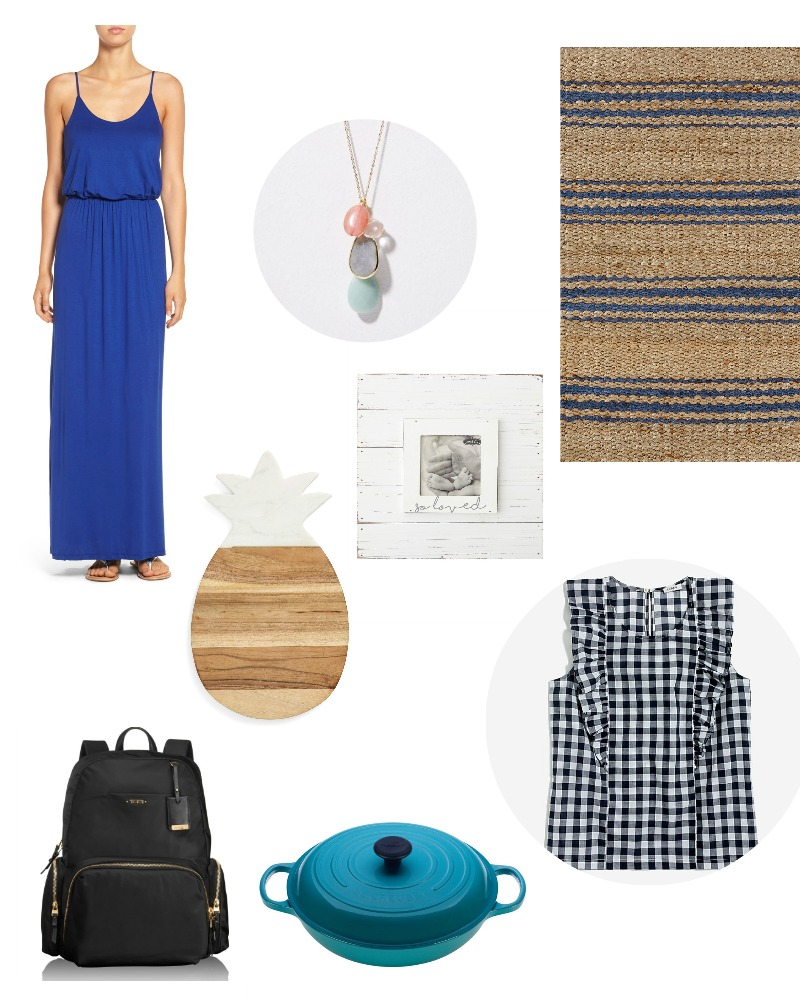Can you tell a detailed story or create a fictional scenario around the items shown in the image? Once upon a time, in a quaint little cottage on the edge of a bustling town, lived a woman named Clara. Clara adored her home, which was a blend of rustic charm and modern elegance. One sunny Saturday morning, she decided to host a small gathering for her closest friends and family. 

Clara wore a stunning blue dress, simple yet elegant, perfect for the warm weather. She teamed it up with a delicate necklace, adding a touch of grace to her attire. Her best friend Jane arrived early, wearing a stylish checkered top, ready to help Clara with the preparations. 

They began by arranging the living room, spreading out a jute rug that gave a natural, earthy feel to the space. On the kitchen countertop, they placed a beautifully crafted pineapple cutting board, a favorite of Clara’s for its unique design.

Cooking was Clara’s passion, and she loved using her teal cast iron pot to prepare delicious meals. Today, she decided to make a hearty stew. As she cooked, Jane arranged snacks and drinks in the living room. The rustic wooden frame holding a cherished black and white family photo was placed in a prominent spot, reminding everyone of the bond they shared.

Clara’s daughter, Lily, entered the scene carrying a sleek black backpack. She had just returned from an errand, and the gold details of her bag caught everyone’s eye. The backpack was practical yet stylish, a perfect reflection of Lily’s personality.

As the house filled with the rich aroma of stew and the sound of laughter, Clara looked around, feeling a sense of warmth and contentment. The items in her home, simple yet thoughtfully selected, contributed to a space that was welcoming and filled with love. The day was a beautiful medley of good food, great company, and memorable moments. What if these items were part of a mystery story? How would they fit into the plot? In the quiet town of Willow Creek, where everyone knew everyone, an unexpected mystery began to unfold. Clara, a local artist, was the center of attention when a valuable piece of her artwork went missing. The only clues left behind were seemingly mundane household items, yet each held a deeper significance. 

The detective, a sharp-eyed sleuth with a penchant for detail, began his investigation in Clara's home. Clara had worn a blue dress on the night of the theft, the sharegpt4v/same color as the distinctive mark left on the window frame, suggesting a struggle or hurried escape. 

The necklace found on the floor near the window was no ordinary piece; it had a hidden compartment containing a tiny key, possibly important in unlocking a crucial part of the case. 

On the jute rug in the living room lay a broken, checkered top button, likely from the culprit's clothing, as Clara and her friends confirmed that none of them wore checkered patterns that evening. 

A well-worn pineapple cutting board in the kitchen showed deep indentations and unusual markings, almost as if someone had used it to hide something sharp or damaging temporarily. 

The rustic photo frame, holding a cherished black and white family photo, now had curious fingerprints smudged on the glass, a clear sign of someone searching for or removing a hidden item behind the photo. 

In the kitchen, the detective found an upturned teal cast iron pot used to bluntly mask the sound of breaking glass, muffling the intrusion. Finally, the black backpack with gold details left in a corner revealed its hidden compartments, but more tellingly, it contained a scrap of paper with a partial map and obscure notations hinting at the artwork's new location.

Each item contributed to the unfolding mystery, painting a vivid picture of the thief's actions and motives, leading the detective closer to solving the case. 